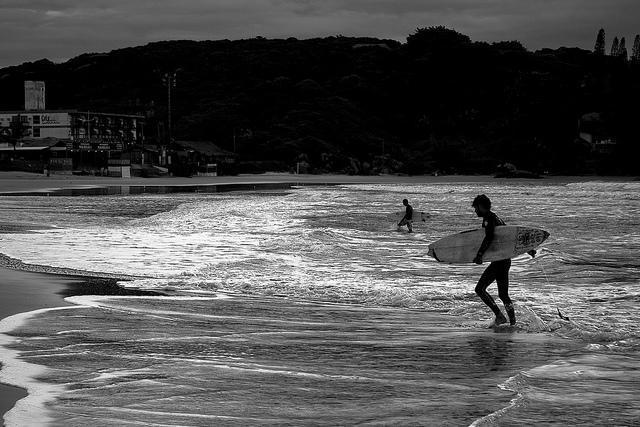How many surfers are there?
Give a very brief answer. 2. 